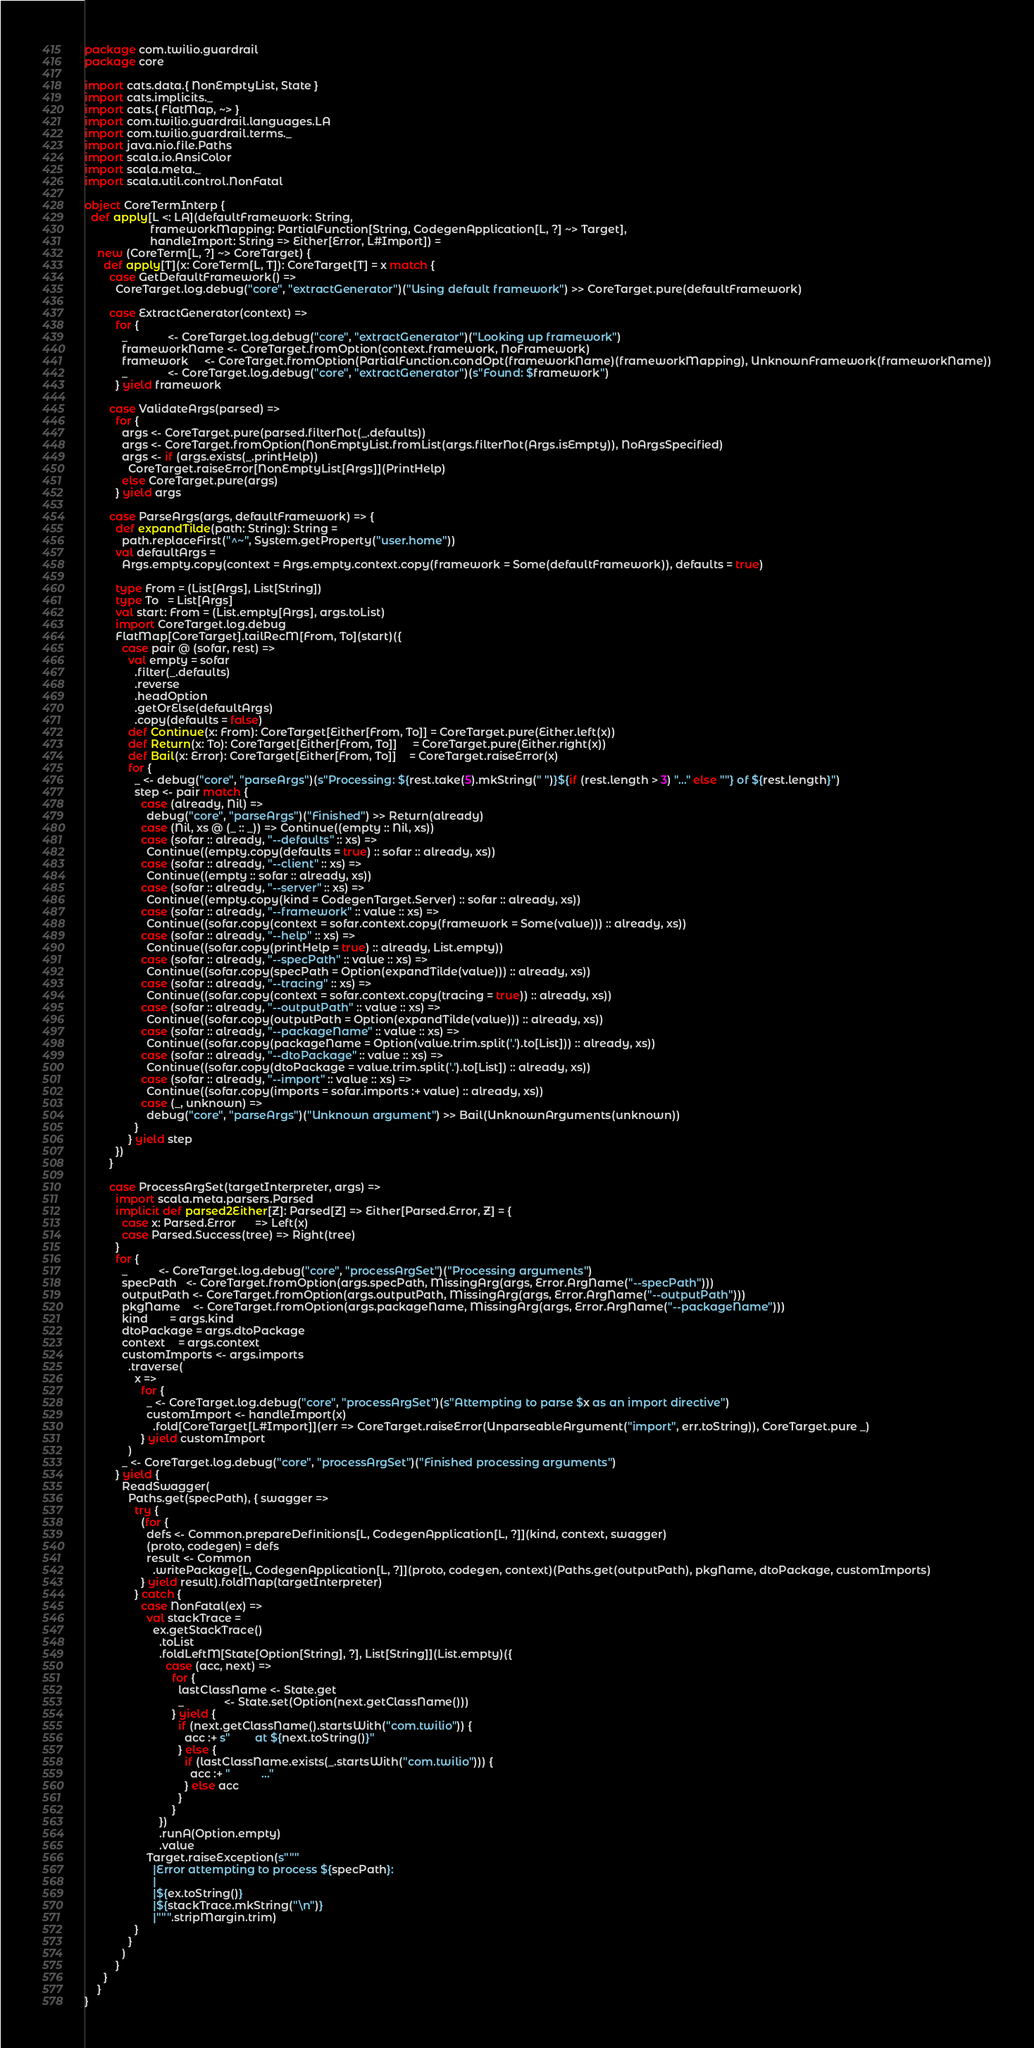<code> <loc_0><loc_0><loc_500><loc_500><_Scala_>package com.twilio.guardrail
package core

import cats.data.{ NonEmptyList, State }
import cats.implicits._
import cats.{ FlatMap, ~> }
import com.twilio.guardrail.languages.LA
import com.twilio.guardrail.terms._
import java.nio.file.Paths
import scala.io.AnsiColor
import scala.meta._
import scala.util.control.NonFatal

object CoreTermInterp {
  def apply[L <: LA](defaultFramework: String,
                     frameworkMapping: PartialFunction[String, CodegenApplication[L, ?] ~> Target],
                     handleImport: String => Either[Error, L#Import]) =
    new (CoreTerm[L, ?] ~> CoreTarget) {
      def apply[T](x: CoreTerm[L, T]): CoreTarget[T] = x match {
        case GetDefaultFramework() =>
          CoreTarget.log.debug("core", "extractGenerator")("Using default framework") >> CoreTarget.pure(defaultFramework)

        case ExtractGenerator(context) =>
          for {
            _             <- CoreTarget.log.debug("core", "extractGenerator")("Looking up framework")
            frameworkName <- CoreTarget.fromOption(context.framework, NoFramework)
            framework     <- CoreTarget.fromOption(PartialFunction.condOpt(frameworkName)(frameworkMapping), UnknownFramework(frameworkName))
            _             <- CoreTarget.log.debug("core", "extractGenerator")(s"Found: $framework")
          } yield framework

        case ValidateArgs(parsed) =>
          for {
            args <- CoreTarget.pure(parsed.filterNot(_.defaults))
            args <- CoreTarget.fromOption(NonEmptyList.fromList(args.filterNot(Args.isEmpty)), NoArgsSpecified)
            args <- if (args.exists(_.printHelp))
              CoreTarget.raiseError[NonEmptyList[Args]](PrintHelp)
            else CoreTarget.pure(args)
          } yield args

        case ParseArgs(args, defaultFramework) => {
          def expandTilde(path: String): String =
            path.replaceFirst("^~", System.getProperty("user.home"))
          val defaultArgs =
            Args.empty.copy(context = Args.empty.context.copy(framework = Some(defaultFramework)), defaults = true)

          type From = (List[Args], List[String])
          type To   = List[Args]
          val start: From = (List.empty[Args], args.toList)
          import CoreTarget.log.debug
          FlatMap[CoreTarget].tailRecM[From, To](start)({
            case pair @ (sofar, rest) =>
              val empty = sofar
                .filter(_.defaults)
                .reverse
                .headOption
                .getOrElse(defaultArgs)
                .copy(defaults = false)
              def Continue(x: From): CoreTarget[Either[From, To]] = CoreTarget.pure(Either.left(x))
              def Return(x: To): CoreTarget[Either[From, To]]     = CoreTarget.pure(Either.right(x))
              def Bail(x: Error): CoreTarget[Either[From, To]]    = CoreTarget.raiseError(x)
              for {
                _ <- debug("core", "parseArgs")(s"Processing: ${rest.take(5).mkString(" ")}${if (rest.length > 3) "..." else ""} of ${rest.length}")
                step <- pair match {
                  case (already, Nil) =>
                    debug("core", "parseArgs")("Finished") >> Return(already)
                  case (Nil, xs @ (_ :: _)) => Continue((empty :: Nil, xs))
                  case (sofar :: already, "--defaults" :: xs) =>
                    Continue((empty.copy(defaults = true) :: sofar :: already, xs))
                  case (sofar :: already, "--client" :: xs) =>
                    Continue((empty :: sofar :: already, xs))
                  case (sofar :: already, "--server" :: xs) =>
                    Continue((empty.copy(kind = CodegenTarget.Server) :: sofar :: already, xs))
                  case (sofar :: already, "--framework" :: value :: xs) =>
                    Continue((sofar.copy(context = sofar.context.copy(framework = Some(value))) :: already, xs))
                  case (sofar :: already, "--help" :: xs) =>
                    Continue((sofar.copy(printHelp = true) :: already, List.empty))
                  case (sofar :: already, "--specPath" :: value :: xs) =>
                    Continue((sofar.copy(specPath = Option(expandTilde(value))) :: already, xs))
                  case (sofar :: already, "--tracing" :: xs) =>
                    Continue((sofar.copy(context = sofar.context.copy(tracing = true)) :: already, xs))
                  case (sofar :: already, "--outputPath" :: value :: xs) =>
                    Continue((sofar.copy(outputPath = Option(expandTilde(value))) :: already, xs))
                  case (sofar :: already, "--packageName" :: value :: xs) =>
                    Continue((sofar.copy(packageName = Option(value.trim.split('.').to[List])) :: already, xs))
                  case (sofar :: already, "--dtoPackage" :: value :: xs) =>
                    Continue((sofar.copy(dtoPackage = value.trim.split('.').to[List]) :: already, xs))
                  case (sofar :: already, "--import" :: value :: xs) =>
                    Continue((sofar.copy(imports = sofar.imports :+ value) :: already, xs))
                  case (_, unknown) =>
                    debug("core", "parseArgs")("Unknown argument") >> Bail(UnknownArguments(unknown))
                }
              } yield step
          })
        }

        case ProcessArgSet(targetInterpreter, args) =>
          import scala.meta.parsers.Parsed
          implicit def parsed2Either[Z]: Parsed[Z] => Either[Parsed.Error, Z] = {
            case x: Parsed.Error      => Left(x)
            case Parsed.Success(tree) => Right(tree)
          }
          for {
            _          <- CoreTarget.log.debug("core", "processArgSet")("Processing arguments")
            specPath   <- CoreTarget.fromOption(args.specPath, MissingArg(args, Error.ArgName("--specPath")))
            outputPath <- CoreTarget.fromOption(args.outputPath, MissingArg(args, Error.ArgName("--outputPath")))
            pkgName    <- CoreTarget.fromOption(args.packageName, MissingArg(args, Error.ArgName("--packageName")))
            kind       = args.kind
            dtoPackage = args.dtoPackage
            context    = args.context
            customImports <- args.imports
              .traverse(
                x =>
                  for {
                    _ <- CoreTarget.log.debug("core", "processArgSet")(s"Attempting to parse $x as an import directive")
                    customImport <- handleImport(x)
                      .fold[CoreTarget[L#Import]](err => CoreTarget.raiseError(UnparseableArgument("import", err.toString)), CoreTarget.pure _)
                  } yield customImport
              )
            _ <- CoreTarget.log.debug("core", "processArgSet")("Finished processing arguments")
          } yield {
            ReadSwagger(
              Paths.get(specPath), { swagger =>
                try {
                  (for {
                    defs <- Common.prepareDefinitions[L, CodegenApplication[L, ?]](kind, context, swagger)
                    (proto, codegen) = defs
                    result <- Common
                      .writePackage[L, CodegenApplication[L, ?]](proto, codegen, context)(Paths.get(outputPath), pkgName, dtoPackage, customImports)
                  } yield result).foldMap(targetInterpreter)
                } catch {
                  case NonFatal(ex) =>
                    val stackTrace =
                      ex.getStackTrace()
                        .toList
                        .foldLeftM[State[Option[String], ?], List[String]](List.empty)({
                          case (acc, next) =>
                            for {
                              lastClassName <- State.get
                              _             <- State.set(Option(next.getClassName()))
                            } yield {
                              if (next.getClassName().startsWith("com.twilio")) {
                                acc :+ s"        at ${next.toString()}"
                              } else {
                                if (lastClassName.exists(_.startsWith("com.twilio"))) {
                                  acc :+ "          ..."
                                } else acc
                              }
                            }
                        })
                        .runA(Option.empty)
                        .value
                    Target.raiseException(s"""
                      |Error attempting to process ${specPath}:
                      |
                      |${ex.toString()}
                      |${stackTrace.mkString("\n")}
                      |""".stripMargin.trim)
                }
              }
            )
          }
      }
    }
}
</code> 